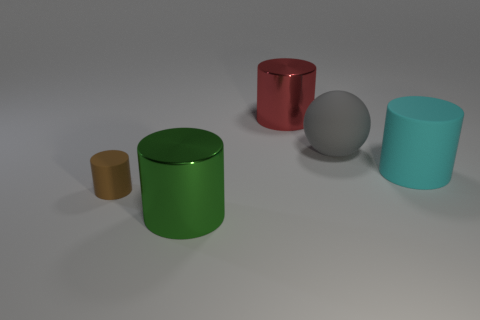Subtract all cyan matte cylinders. How many cylinders are left? 3 Subtract 1 cylinders. How many cylinders are left? 3 Add 2 large red metallic objects. How many objects exist? 7 Subtract all cyan cylinders. How many cylinders are left? 3 Subtract all spheres. How many objects are left? 4 Subtract all blue spheres. Subtract all red cubes. How many spheres are left? 1 Subtract all cyan matte cylinders. Subtract all green cylinders. How many objects are left? 3 Add 1 large green metallic objects. How many large green metallic objects are left? 2 Add 3 big green things. How many big green things exist? 4 Subtract 0 green balls. How many objects are left? 5 